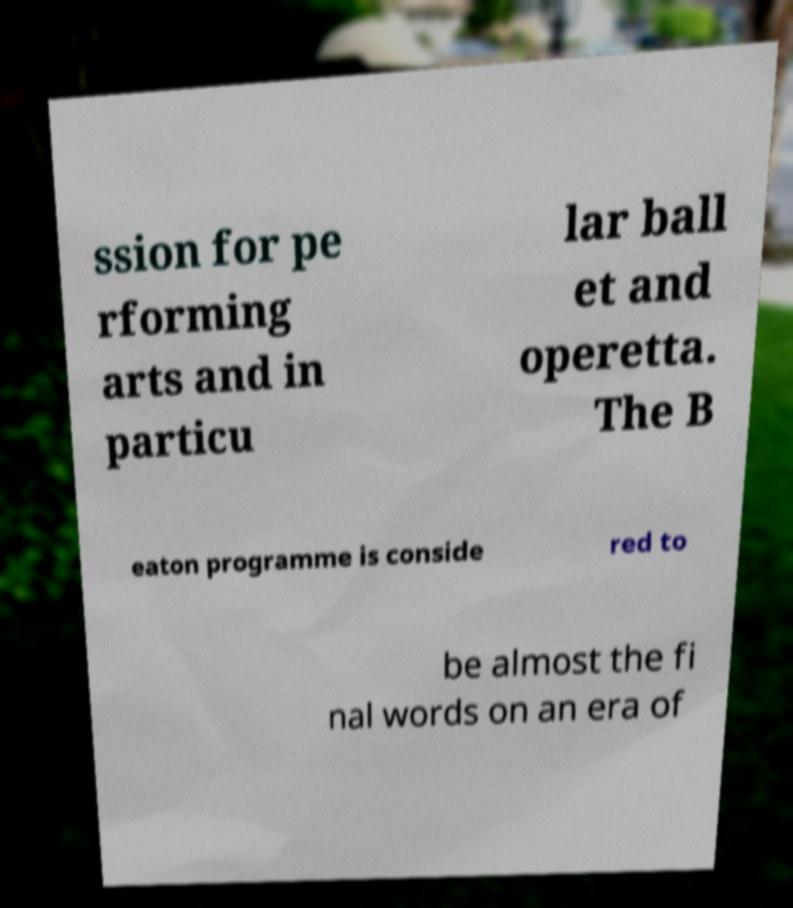I need the written content from this picture converted into text. Can you do that? ssion for pe rforming arts and in particu lar ball et and operetta. The B eaton programme is conside red to be almost the fi nal words on an era of 